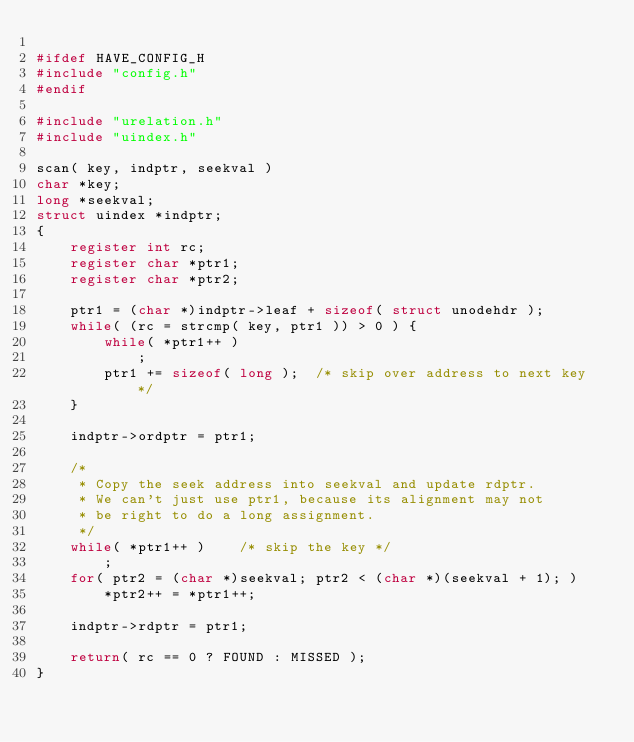<code> <loc_0><loc_0><loc_500><loc_500><_C_>
#ifdef HAVE_CONFIG_H
#include "config.h"
#endif

#include "urelation.h"
#include "uindex.h"

scan( key, indptr, seekval )
char *key;
long *seekval; 
struct uindex *indptr;
{
	register int rc;
	register char *ptr1;
	register char *ptr2;

	ptr1 = (char *)indptr->leaf + sizeof( struct unodehdr );
	while( (rc = strcmp( key, ptr1 )) > 0 ) {
		while( *ptr1++ )
			;
		ptr1 += sizeof( long );  /* skip over address to next key */
	}

	indptr->ordptr = ptr1;

	/*
	 * Copy the seek address into seekval and update rdptr.
	 * We can't just use ptr1, because its alignment may not
	 * be right to do a long assignment.
	 */
	while( *ptr1++ )	/* skip the key */
		;
	for( ptr2 = (char *)seekval; ptr2 < (char *)(seekval + 1); )
		*ptr2++ = *ptr1++;

	indptr->rdptr = ptr1;

	return( rc == 0 ? FOUND : MISSED );
}
</code> 